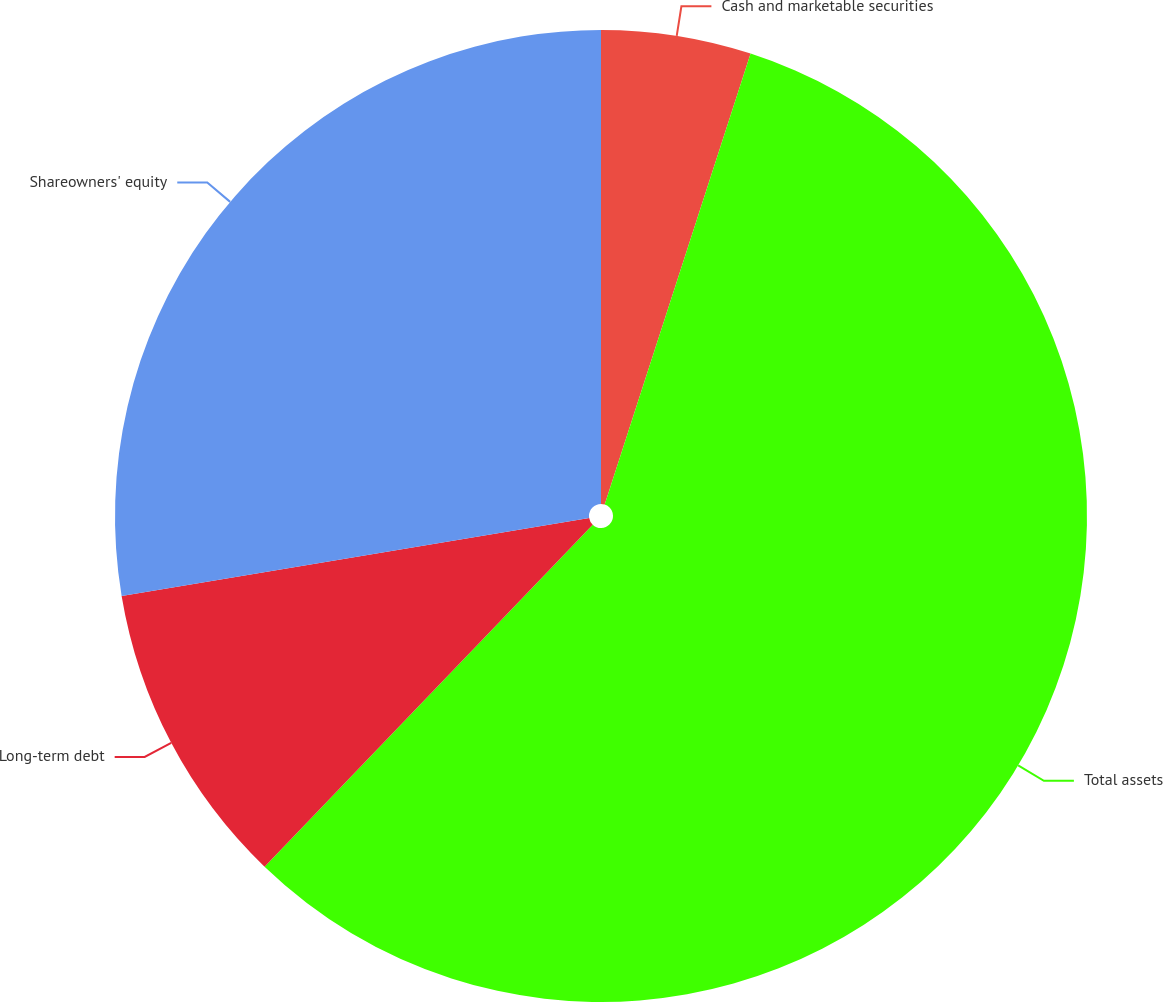<chart> <loc_0><loc_0><loc_500><loc_500><pie_chart><fcel>Cash and marketable securities<fcel>Total assets<fcel>Long-term debt<fcel>Shareowners' equity<nl><fcel>4.98%<fcel>57.19%<fcel>10.2%<fcel>27.63%<nl></chart> 